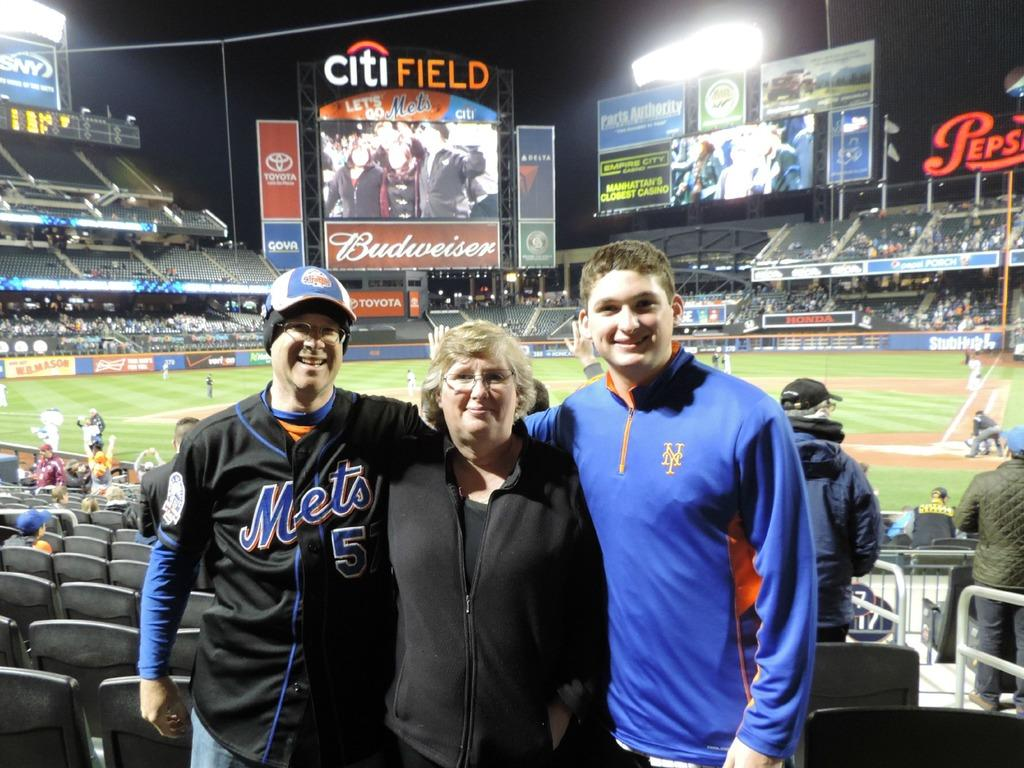<image>
Give a short and clear explanation of the subsequent image. Two men and older women pose for a picture inside the City Field Baseball stadium with the TV screen in the background. 